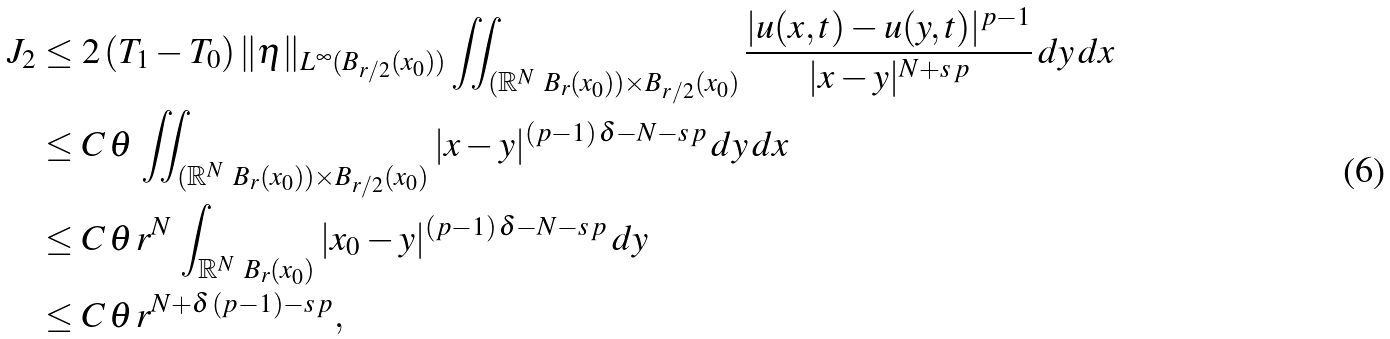<formula> <loc_0><loc_0><loc_500><loc_500>J _ { 2 } & \leq 2 \, ( T _ { 1 } - T _ { 0 } ) \, \| \eta \| _ { L ^ { \infty } ( B _ { r / 2 } ( x _ { 0 } ) ) } \iint _ { ( \mathbb { R } ^ { N } \ B _ { r } ( x _ { 0 } ) ) \times B _ { r / 2 } ( x _ { 0 } ) } \frac { | u ( x , t ) - u ( y , t ) | ^ { p - 1 } } { | x - y | ^ { N + s \, p } } \, d y \, d x \\ & \leq C \, \theta \, \iint _ { ( \mathbb { R } ^ { N } \ B _ { r } ( x _ { 0 } ) ) \times B _ { r / 2 } ( x _ { 0 } ) } | x - y | ^ { ( p - 1 ) \, \delta - N - s \, p } \, d y \, d x \\ & \leq C \, \theta \, r ^ { N } \, \int _ { \mathbb { R } ^ { N } \ B _ { r } ( x _ { 0 } ) } | x _ { 0 } - y | ^ { ( p - 1 ) \, \delta - N - s \, p } \, d y \\ & \leq C \, \theta \, r ^ { N + \delta \, ( p - 1 ) - s \, p } ,</formula> 